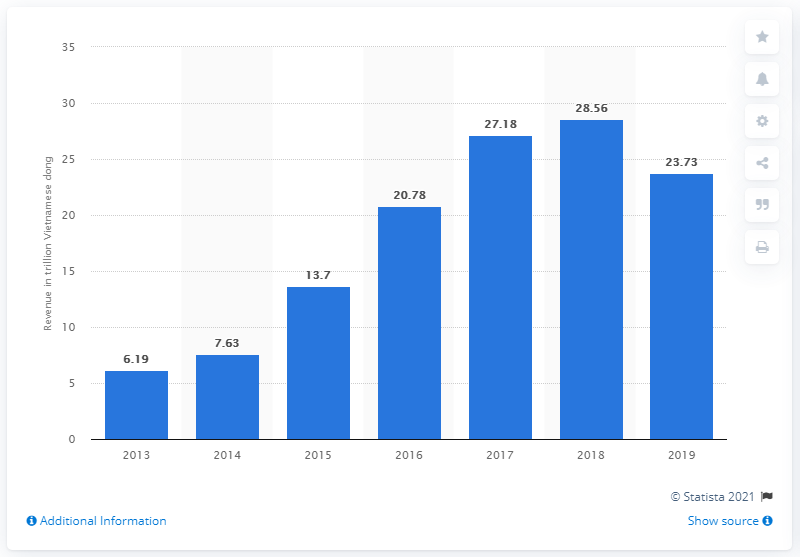Identify some key points in this picture. In 2019, Coteccons Construction's revenue was 23.73 million. 